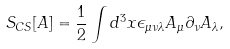<formula> <loc_0><loc_0><loc_500><loc_500>S _ { C S } [ A ] = \frac { 1 } { 2 } \int d ^ { 3 } x \epsilon _ { \mu \nu \lambda } A _ { \mu } \partial _ { \nu } A _ { \lambda } ,</formula> 